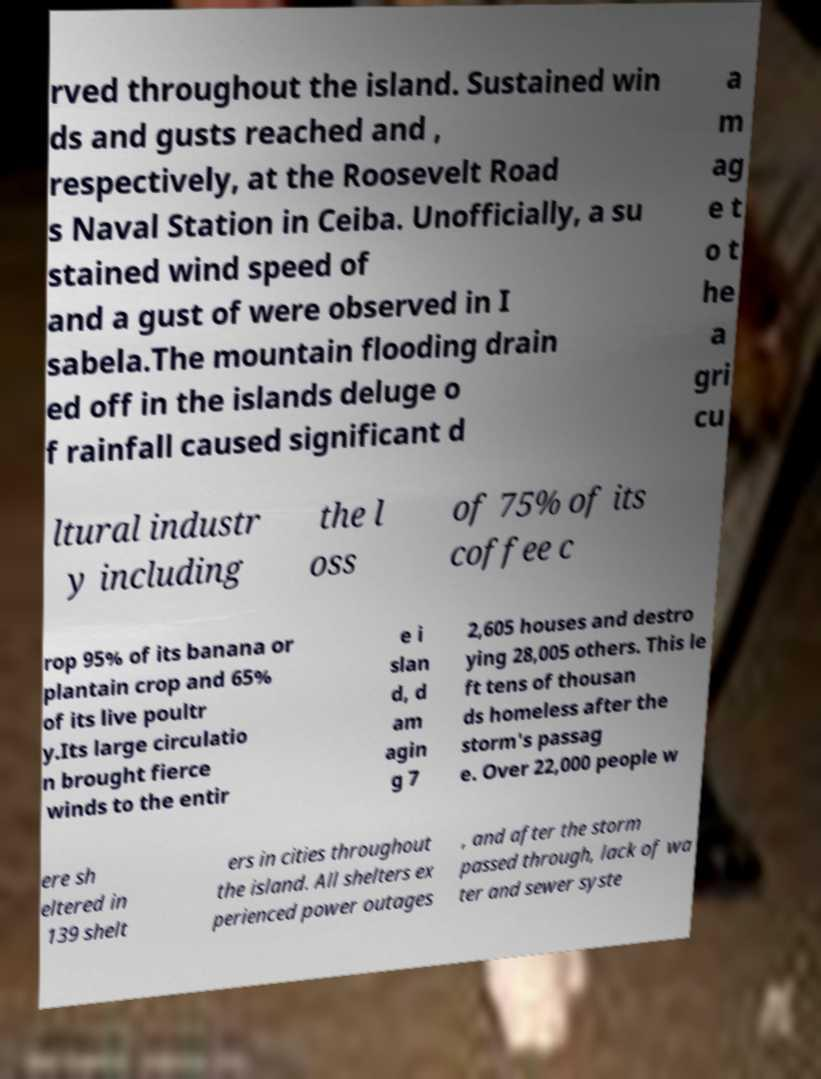What messages or text are displayed in this image? I need them in a readable, typed format. rved throughout the island. Sustained win ds and gusts reached and , respectively, at the Roosevelt Road s Naval Station in Ceiba. Unofficially, a su stained wind speed of and a gust of were observed in I sabela.The mountain flooding drain ed off in the islands deluge o f rainfall caused significant d a m ag e t o t he a gri cu ltural industr y including the l oss of 75% of its coffee c rop 95% of its banana or plantain crop and 65% of its live poultr y.Its large circulatio n brought fierce winds to the entir e i slan d, d am agin g 7 2,605 houses and destro ying 28,005 others. This le ft tens of thousan ds homeless after the storm's passag e. Over 22,000 people w ere sh eltered in 139 shelt ers in cities throughout the island. All shelters ex perienced power outages , and after the storm passed through, lack of wa ter and sewer syste 